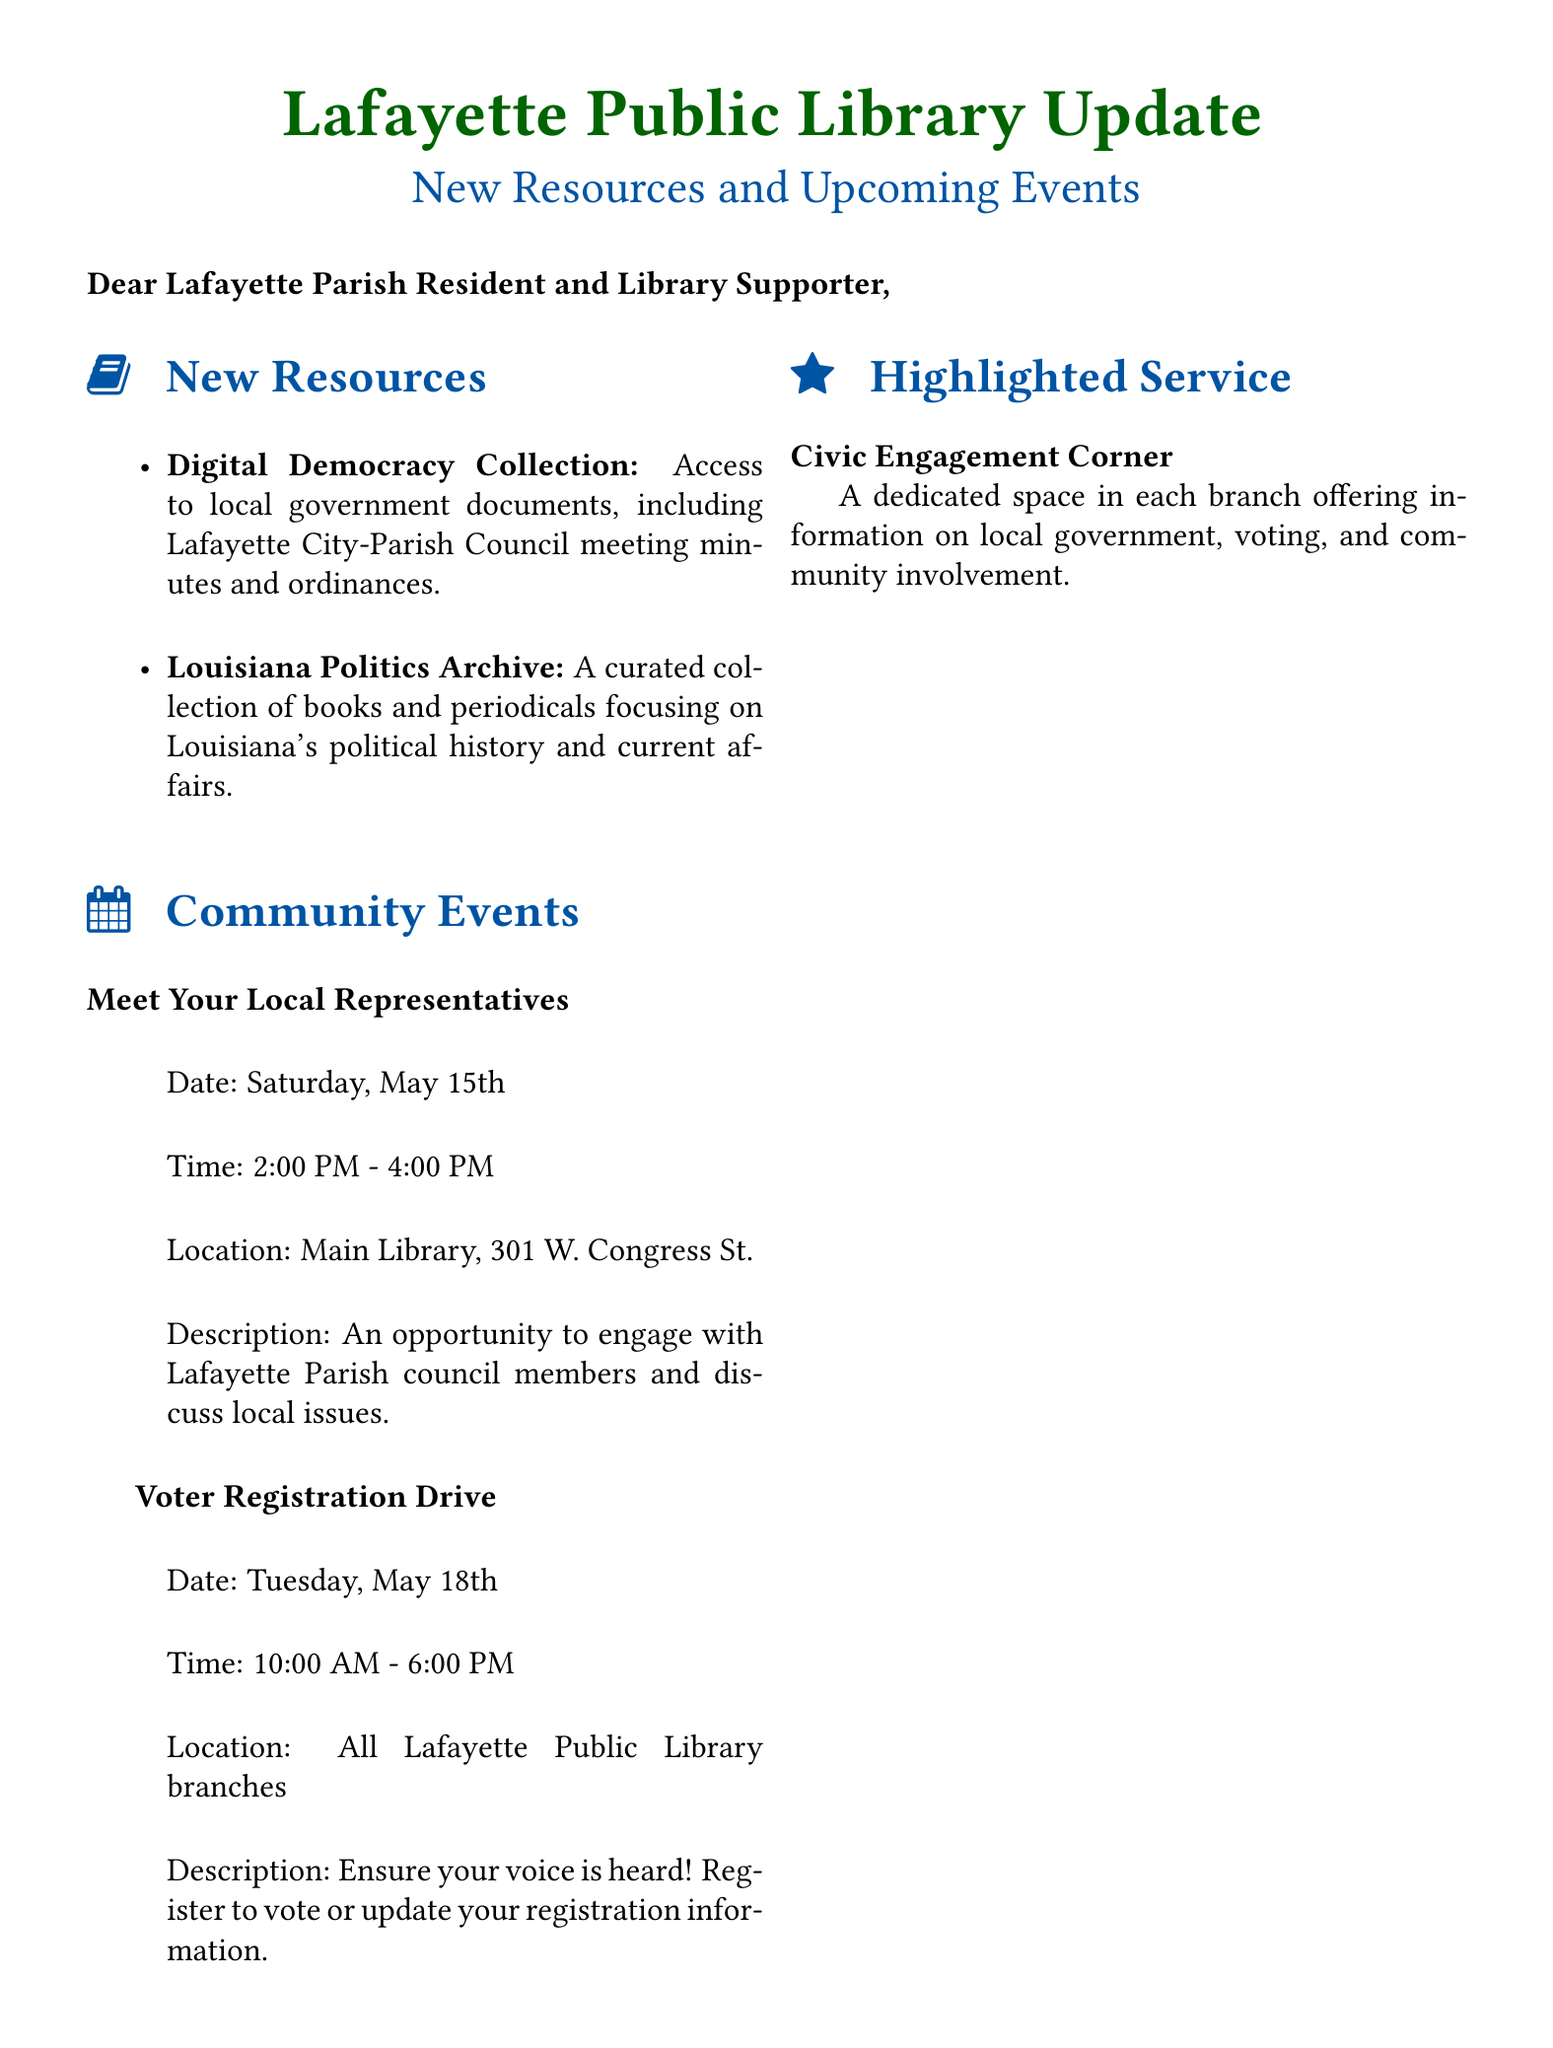what is the subject of the email? The subject of the email is stated clearly at the beginning of the document.
Answer: Lafayette Public Library Update: New Resources and Upcoming Events what is the date of the "Meet Your Local Representatives" event? The date of the event is provided in the community events section of the document.
Answer: Saturday, May 15th what is the time of the Voter Registration Drive? The time is indicated next to the event name in the community events section.
Answer: 10:00 AM - 6:00 PM who is the director of the Lafayette Public Library? The director's name is mentioned in the closing part of the document.
Answer: Teresa Elberson what is the purpose of the "Civic Engagement Corner"? The purpose is briefly described in the highlighted service section of the document.
Answer: Offer information on local government, voting, and community involvement how many community events are listed in the document? The document provides a count of events listed in the community events section.
Answer: 2 which library branch location is specified for the "Meet Your Local Representatives" event? The location of the event is detailed right after its time and date in the document.
Answer: Main Library, 301 W. Congress St what type of documents can be accessed in the Digital Democracy Collection? The types of documents available are specified in the new resources section.
Answer: Local government documents which resource focuses on Louisiana's political history? The resource related to Louisiana's political history is identified in the new resources section.
Answer: Louisiana Politics Archive 